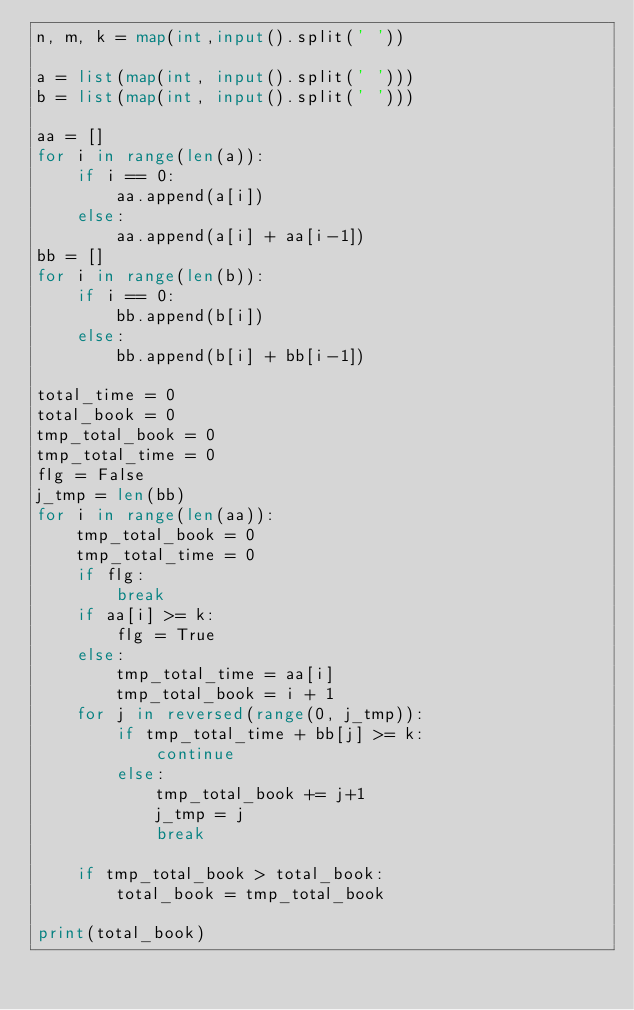Convert code to text. <code><loc_0><loc_0><loc_500><loc_500><_Python_>n, m, k = map(int,input().split(' '))

a = list(map(int, input().split(' ')))
b = list(map(int, input().split(' ')))

aa = []
for i in range(len(a)):
    if i == 0:
        aa.append(a[i])
    else:
        aa.append(a[i] + aa[i-1])
bb = []
for i in range(len(b)):
    if i == 0:
        bb.append(b[i])
    else:
        bb.append(b[i] + bb[i-1])

total_time = 0
total_book = 0
tmp_total_book = 0
tmp_total_time = 0
flg = False
j_tmp = len(bb)
for i in range(len(aa)):
    tmp_total_book = 0
    tmp_total_time = 0
    if flg:
        break
    if aa[i] >= k:
        flg = True
    else:
        tmp_total_time = aa[i]
        tmp_total_book = i + 1
    for j in reversed(range(0, j_tmp)):
        if tmp_total_time + bb[j] >= k:
            continue
        else:
            tmp_total_book += j+1
            j_tmp = j
            break

    if tmp_total_book > total_book:
        total_book = tmp_total_book

print(total_book)



</code> 